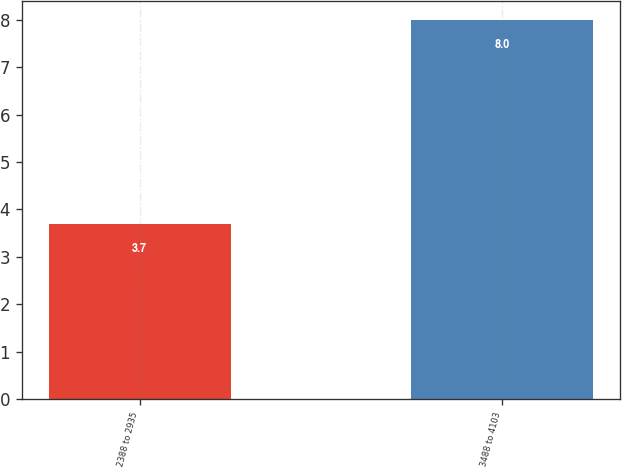Convert chart to OTSL. <chart><loc_0><loc_0><loc_500><loc_500><bar_chart><fcel>2388 to 2935<fcel>3488 to 4103<nl><fcel>3.7<fcel>8<nl></chart> 